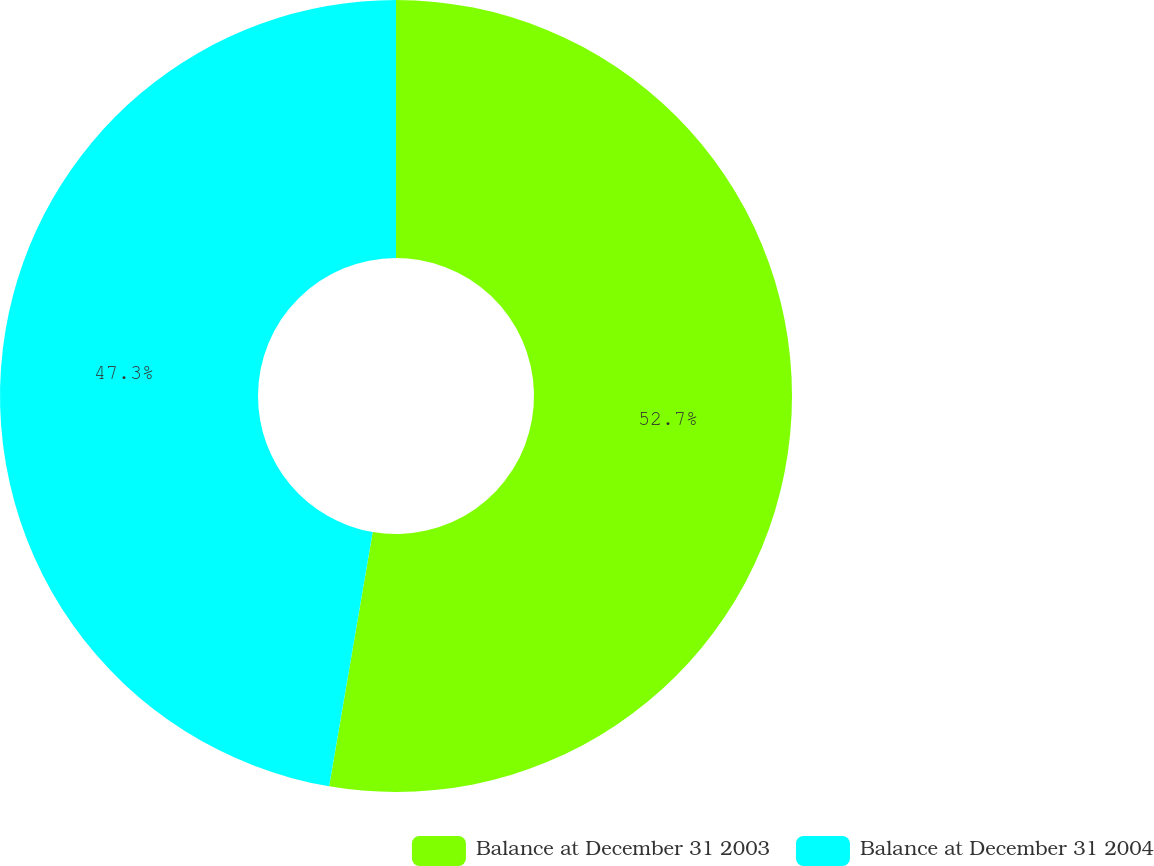Convert chart to OTSL. <chart><loc_0><loc_0><loc_500><loc_500><pie_chart><fcel>Balance at December 31 2003<fcel>Balance at December 31 2004<nl><fcel>52.7%<fcel>47.3%<nl></chart> 